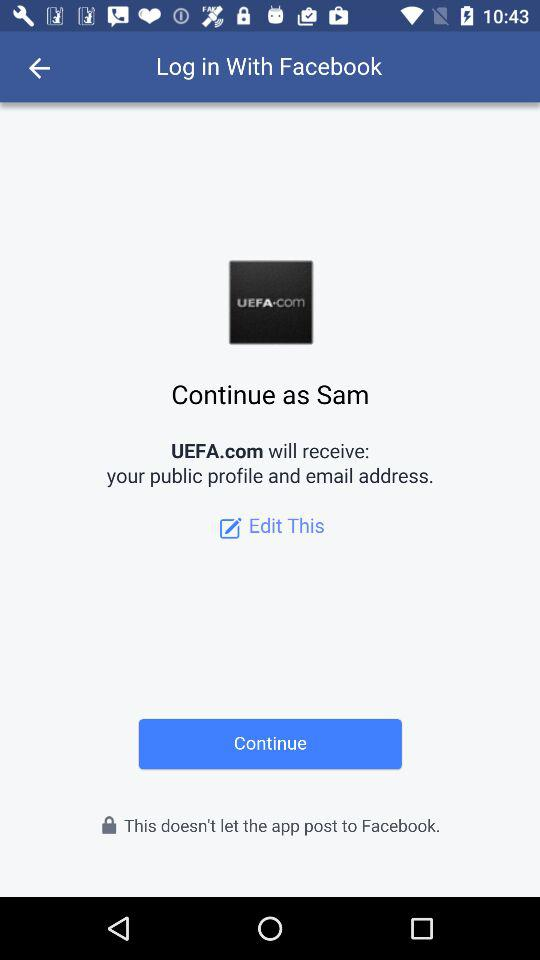What applications can be used to log in to a profile? We can use Facebook to log in to a profile. 